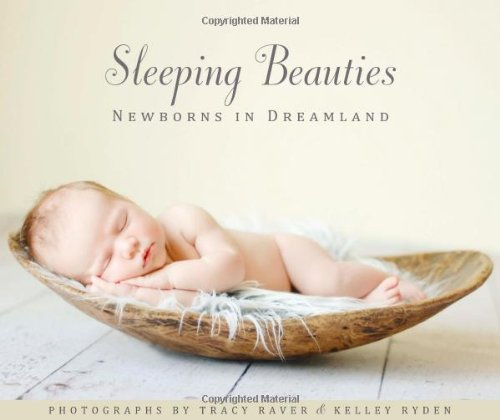What inspires the theme of newborns in this book? The theme of newborns in 'Sleeping Beauties: Newborns in Dreamland' is inspired by the natural, peaceful beauty and innocence of babies in their first days of life, highlighting a time of pure tranquility and new beginnings. 